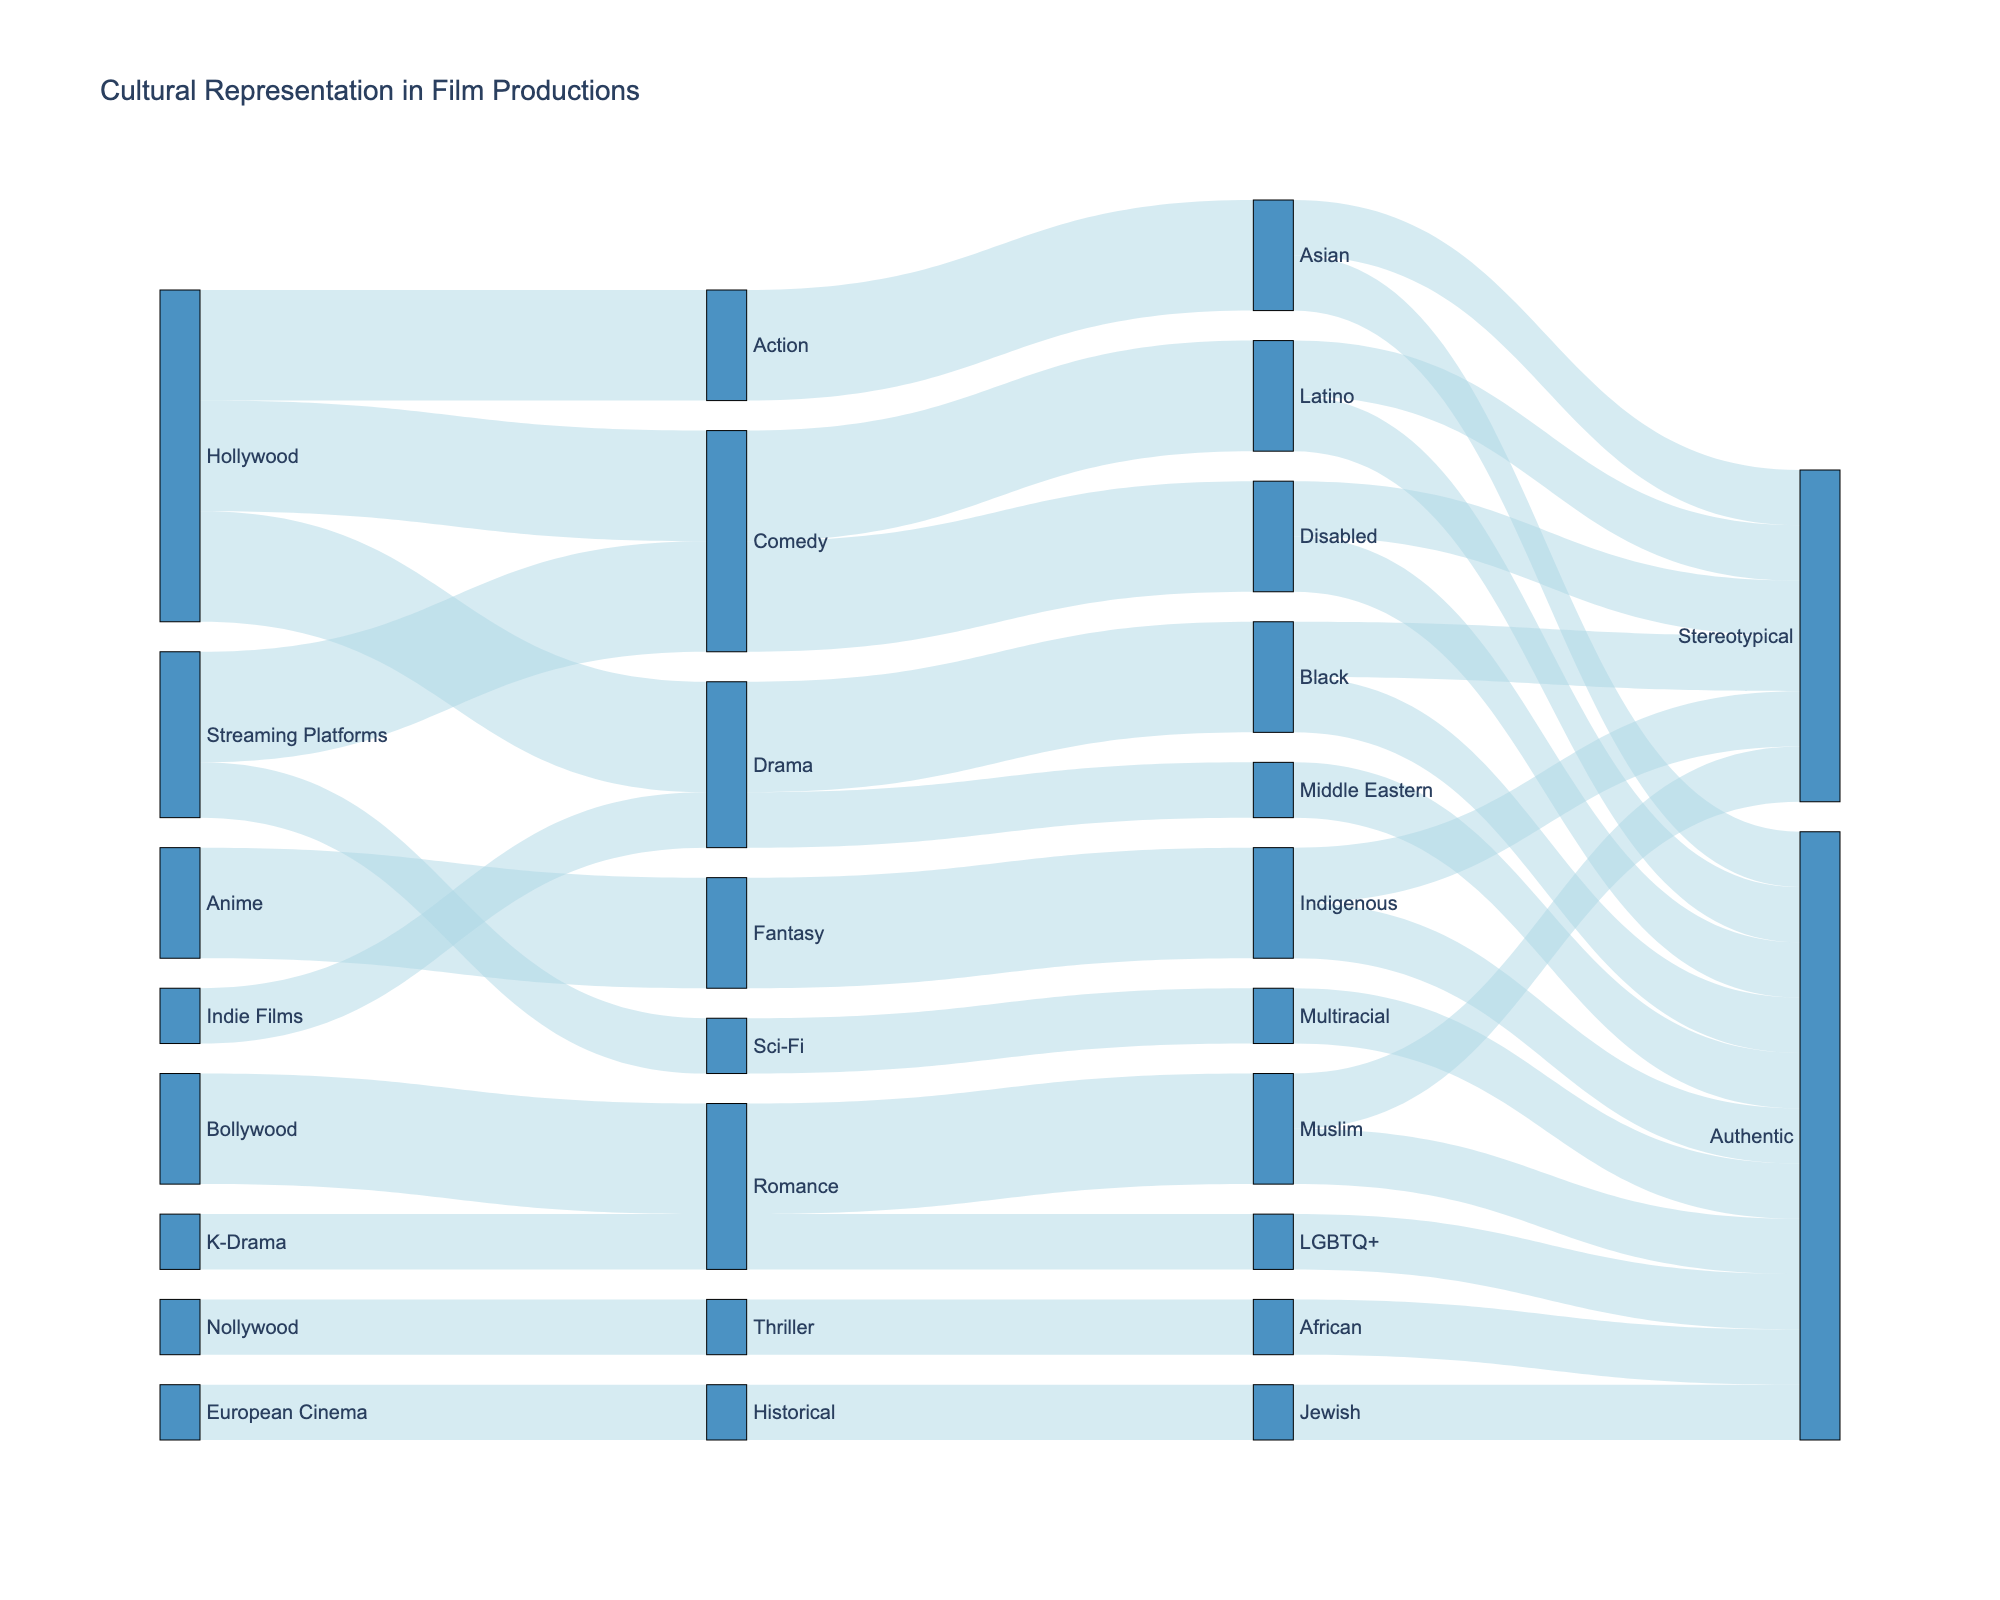What are the main sources depicted in the Sankey Diagram? The main sources are shown at the beginning of the diagram flow, they include: Hollywood, Bollywood, Nollywood, European Cinema, K-Drama, Anime, Indie Films, and Streaming Platforms.
Answer: Hollywood, Bollywood, Nollywood, European Cinema, K-Drama, Anime, Indie Films, Streaming Platforms Which genre has the most authentic representation? By tracing the flows in the Sankey Diagram from genres to outcomes, we can count the number of "Authentic" representations for each genre. Romance has the most flows leading to "Authentic" representation.
Answer: Romance How many "Stereotypical" representations are there in total in the Sankey Diagram? To determine this, count all the flows that end at the "Stereotypical" outcome. From the diagram, we sum the respective values.
Answer: 4 Compare the representation of Asians in the Action genre between "Stereotypical" and "Authentic". Which is greater? Follow the flow for the Action genre and compare the branches that end at "Stereotypical" and "Authentic" for the Asian representation. "Stereotypical" is greater than "Authentic".
Answer: Stereotypical Are there any genres that exclusively have “Authentic” representations? If so, name one. By examining the flows from genre to outcome, we look for genres that only lead to "Authentic" and not to any other outcome. Thriller in Nollywood only has “Authentic” representation.
Answer: Thriller What is the overall theme of the Sankey Diagram? The title of the diagram at the top provides this information. It shows the flow of cultural representation in major film productions across different genres.
Answer: Cultural representation in film productions How many unique representation types are depicted in the diagram? The representation types are shown in one of the intermediary nodes. By listing them out, we count the distinct types.
Answer: 8 Which source has the least diverse genre representation? Track the flows from each source to the genre nodes and count the number of unique genres. European Cinema has only one genre, making it the least diverse in genre representation.
Answer: European Cinema How does the representation of Disabled characters in Streaming Platforms’ Comedy genre differ in outcomes? Follow the flow from Streaming Platforms to Comedy, then from Comedy to Disabled, and finally check the branch outcomes “Stereotypical” and “Authentic”. Both outcomes have representations but not in equal measure.
Answer: Both, but not equally 